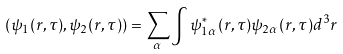<formula> <loc_0><loc_0><loc_500><loc_500>( \psi _ { 1 } ( { r } , \tau ) , \psi _ { 2 } ( { r } , \tau ) ) = \sum _ { \alpha } \int \psi _ { 1 \alpha } ^ { * } ( { r } , \tau ) \psi _ { 2 \alpha } ( { r } , \tau ) d ^ { 3 } { r }</formula> 